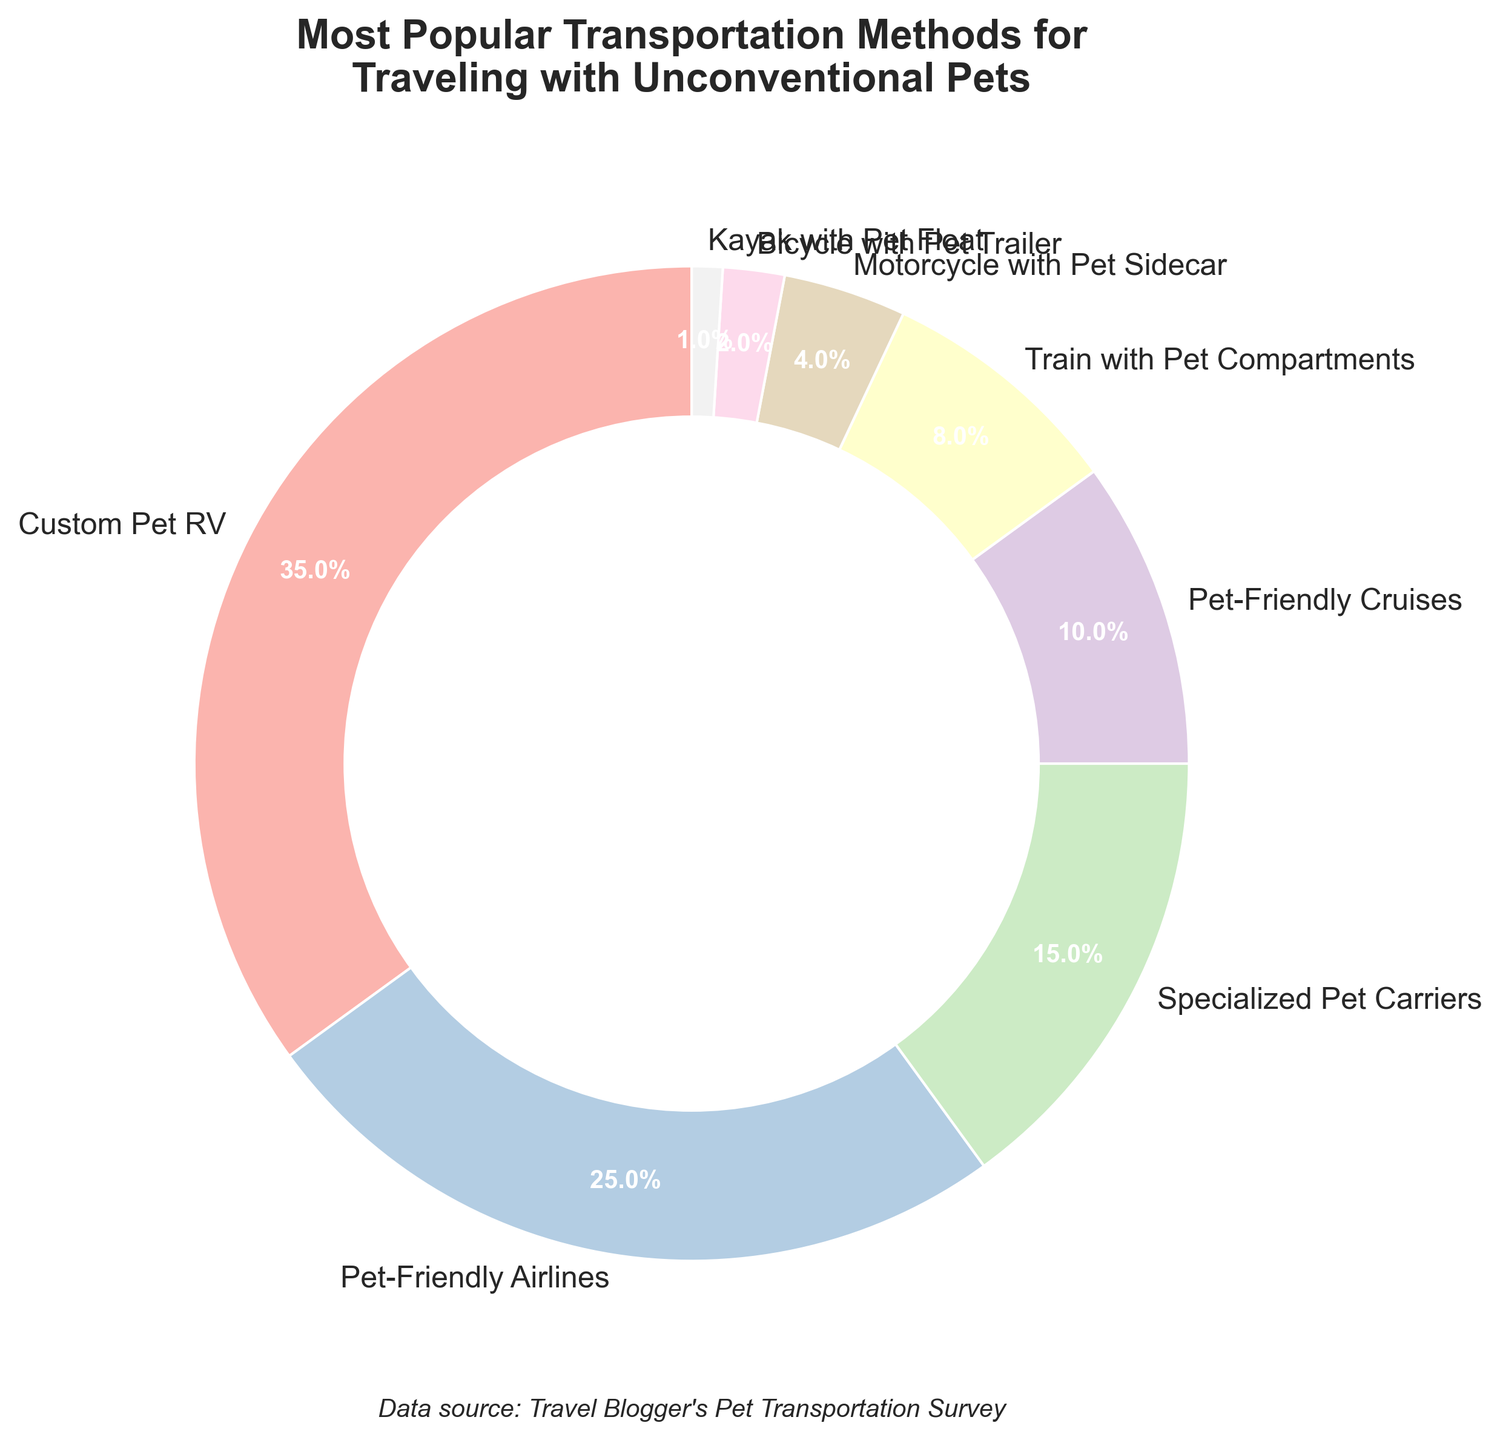What percentage of travelers use Pet-Friendly Airlines? Look at the pie chart section labeled "Pet-Friendly Airlines" and check the percentage mark.
Answer: 25% Which transportation method is used the least for traveling with unconventional pets? Look at the pie chart and identify the segment with the smallest percentage.
Answer: Kayak with Pet Float How much more popular are Custom Pet RVs compared to Pet-Friendly Cruises? Find the percentages for Custom Pet RV (35%) and Pet-Friendly Cruises (10%) from the pie chart and calculate the difference: 35% - 10% = 25%.
Answer: 25% What is the total percentage of travelers using either Trains with Pet Compartments or Motorcycles with Pet Sidecars? Add the percentages of Train with Pet Compartments (8%) and Motorcycle with Pet Sidecar (4%): 8% + 4% = 12%.
Answer: 12% Which transportation methods each account for less than 5% of the total? Identify the pie chart segments with percentages less than 5%.
Answer: Motorcycle with Pet Sidecar, Bicycle with Pet Trailer, Kayak with Pet Float Are there more travelers using Specialized Pet Carriers or Pet-Friendly Cruises? Compare the percentages of Specialized Pet Carriers (15%) and Pet-Friendly Cruises (10%) from the pie chart.
Answer: Specialized Pet Carriers What is the combined percentage of travelers using either Custom Pet RVs or Pet-Friendly Airlines? Add the percentages of Custom Pet RV (35%) and Pet-Friendly Airlines (25%): 35% + 25% = 60%.
Answer: 60% Which transportation method accounts for exactly 15% of the total? Find the segment in the pie chart labeled with the exact percentage 15%.
Answer: Specialized Pet Carriers What is visually unique about the pie chart's presentation? Describe any notable visual attributes of the pie chart, such as the central white circle, the colors, and the size of the text.
Answer: It has a central white circle, pastel colors, and varied font sizes By how much do the percentages differ between the most and least popular transportation methods? Find the percentages of the most popular (Custom Pet RV, 35%) and least popular (Kayak with Pet Float, 1%) methods and calculate the difference: 35% - 1% = 34%.
Answer: 34% 